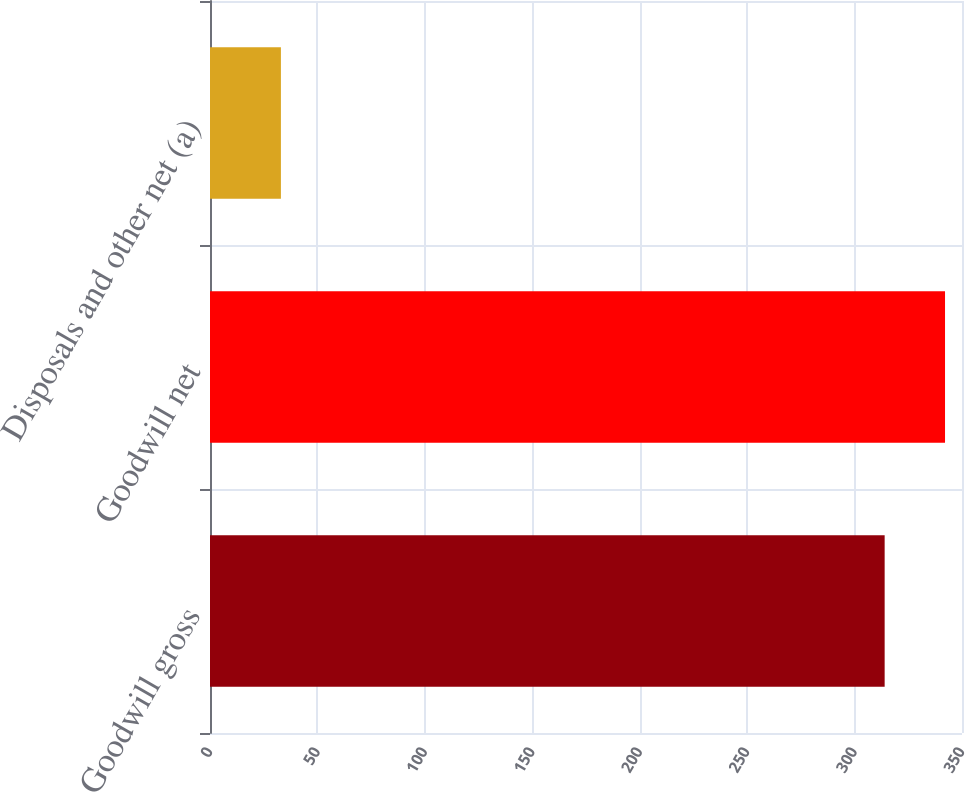<chart> <loc_0><loc_0><loc_500><loc_500><bar_chart><fcel>Goodwill gross<fcel>Goodwill net<fcel>Disposals and other net (a)<nl><fcel>314<fcel>342.1<fcel>33<nl></chart> 